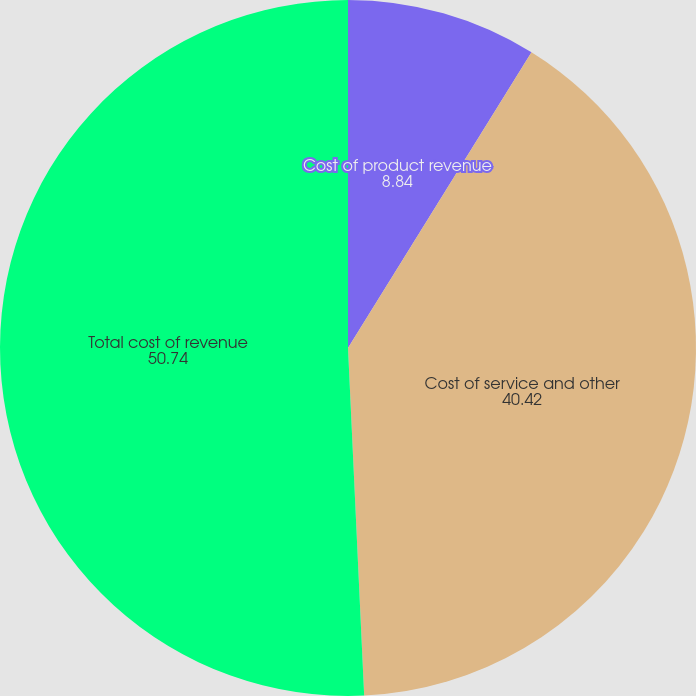<chart> <loc_0><loc_0><loc_500><loc_500><pie_chart><fcel>Cost of product revenue<fcel>Cost of service and other<fcel>Total cost of revenue<nl><fcel>8.84%<fcel>40.42%<fcel>50.74%<nl></chart> 